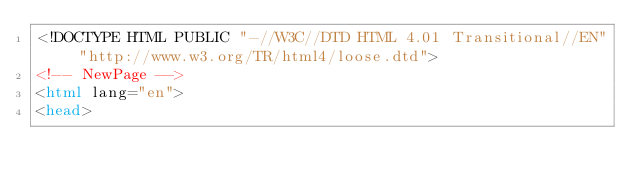Convert code to text. <code><loc_0><loc_0><loc_500><loc_500><_HTML_><!DOCTYPE HTML PUBLIC "-//W3C//DTD HTML 4.01 Transitional//EN" "http://www.w3.org/TR/html4/loose.dtd">
<!-- NewPage -->
<html lang="en">
<head></code> 